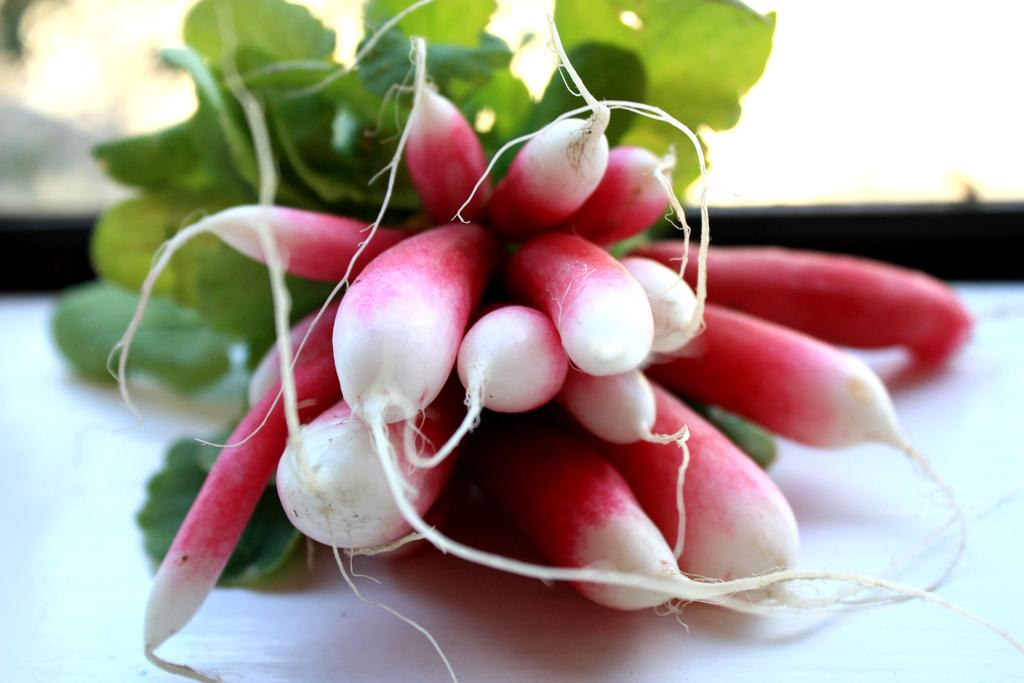What type of vegetable is present in the image? There are radishes in the image. What else can be seen alongside the radishes? There are green leaves in the image. On what surface are the radishes and green leaves placed? The radishes and green leaves are on a white surface. How would you describe the background of the image? The background of the image is blurry. What time is displayed on the clock in the image? There is no clock present in the image; it features radishes and green leaves on a white surface with a blurry background. 